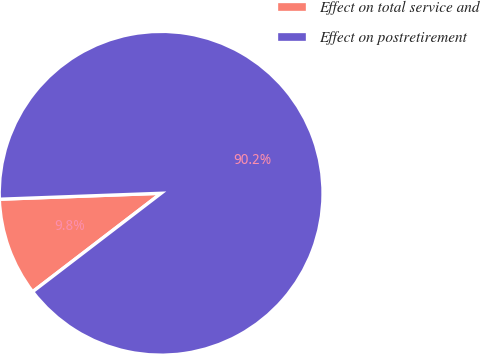<chart> <loc_0><loc_0><loc_500><loc_500><pie_chart><fcel>Effect on total service and<fcel>Effect on postretirement<nl><fcel>9.82%<fcel>90.18%<nl></chart> 